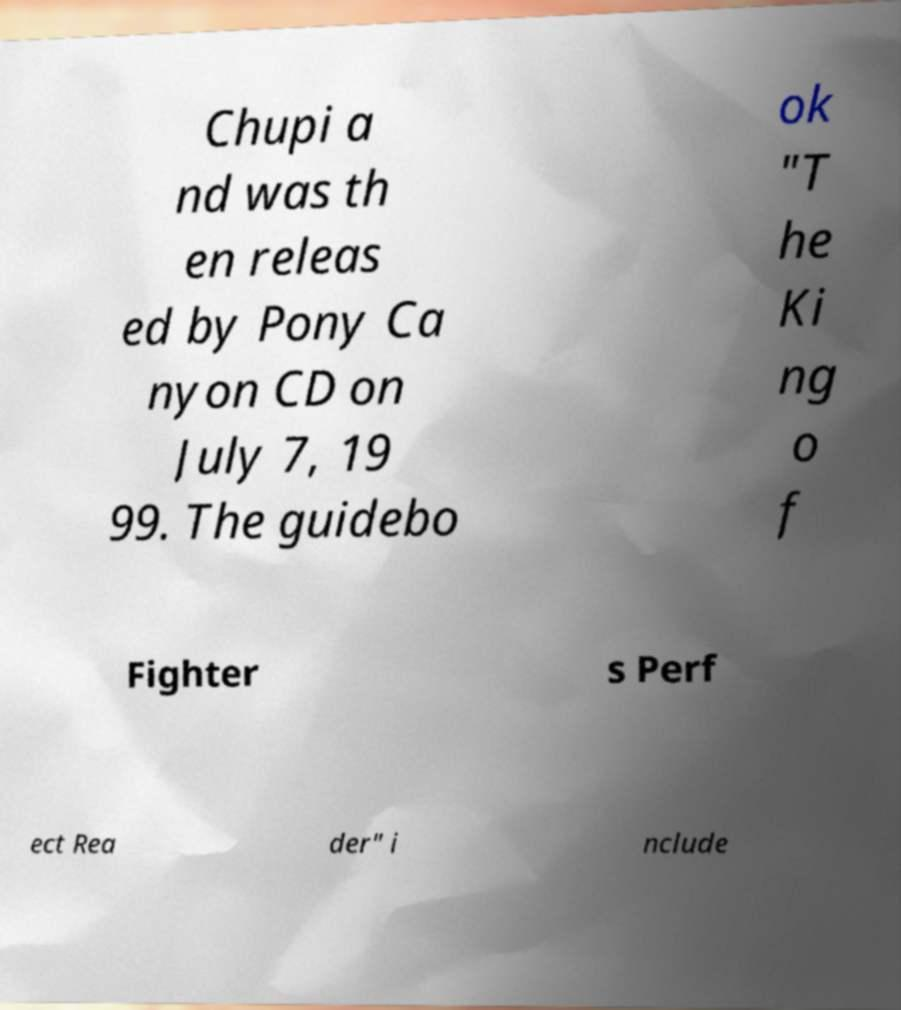Could you extract and type out the text from this image? Chupi a nd was th en releas ed by Pony Ca nyon CD on July 7, 19 99. The guidebo ok "T he Ki ng o f Fighter s Perf ect Rea der" i nclude 